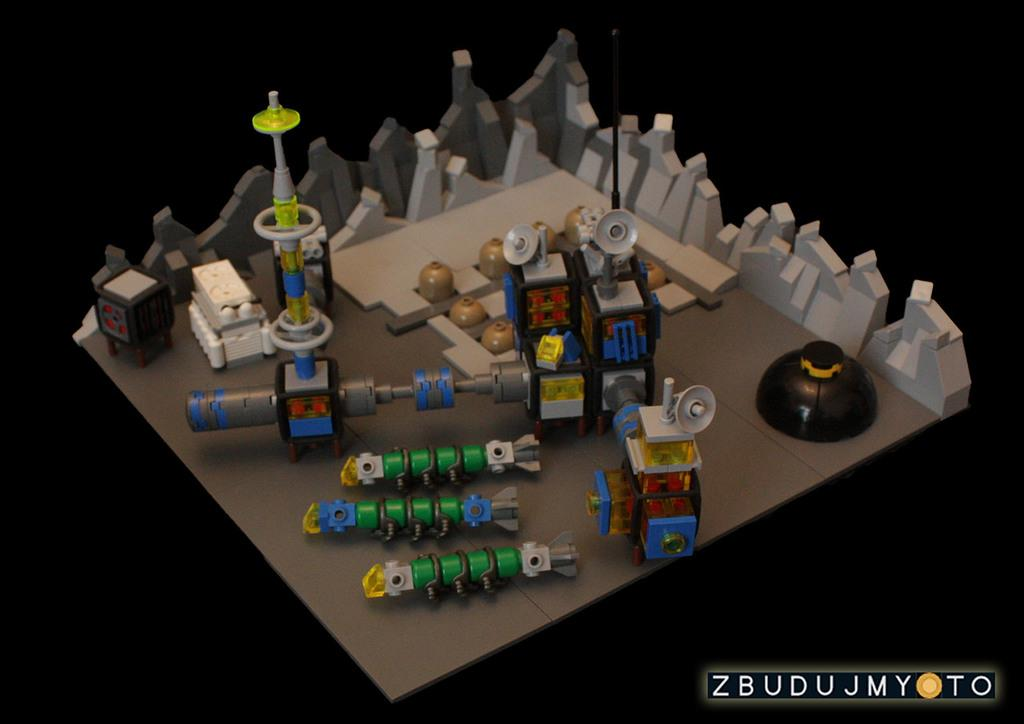What types of objects can be seen in the image? There are different kinds of toys in the image. Can you describe the background of the image? The background of the image is dark. What type of collar is the giraffe wearing in the image? There is no giraffe present in the image, and therefore no collar can be observed. 